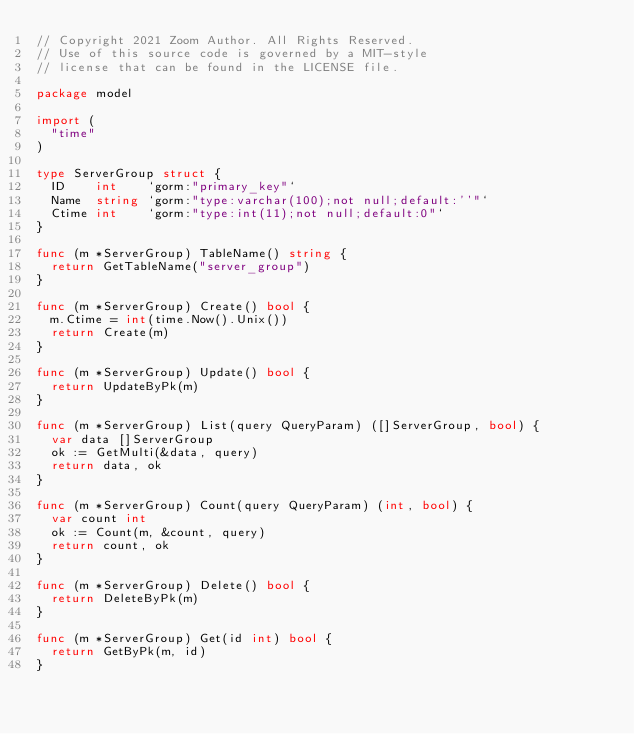Convert code to text. <code><loc_0><loc_0><loc_500><loc_500><_Go_>// Copyright 2021 Zoom Author. All Rights Reserved.
// Use of this source code is governed by a MIT-style
// license that can be found in the LICENSE file.

package model

import (
	"time"
)

type ServerGroup struct {
	ID    int    `gorm:"primary_key"`
	Name  string `gorm:"type:varchar(100);not null;default:''"`
	Ctime int    `gorm:"type:int(11);not null;default:0"`
}

func (m *ServerGroup) TableName() string {
	return GetTableName("server_group")
}

func (m *ServerGroup) Create() bool {
	m.Ctime = int(time.Now().Unix())
	return Create(m)
}

func (m *ServerGroup) Update() bool {
	return UpdateByPk(m)
}

func (m *ServerGroup) List(query QueryParam) ([]ServerGroup, bool) {
	var data []ServerGroup
	ok := GetMulti(&data, query)
	return data, ok
}

func (m *ServerGroup) Count(query QueryParam) (int, bool) {
	var count int
	ok := Count(m, &count, query)
	return count, ok
}

func (m *ServerGroup) Delete() bool {
	return DeleteByPk(m)
}

func (m *ServerGroup) Get(id int) bool {
	return GetByPk(m, id)
}
</code> 